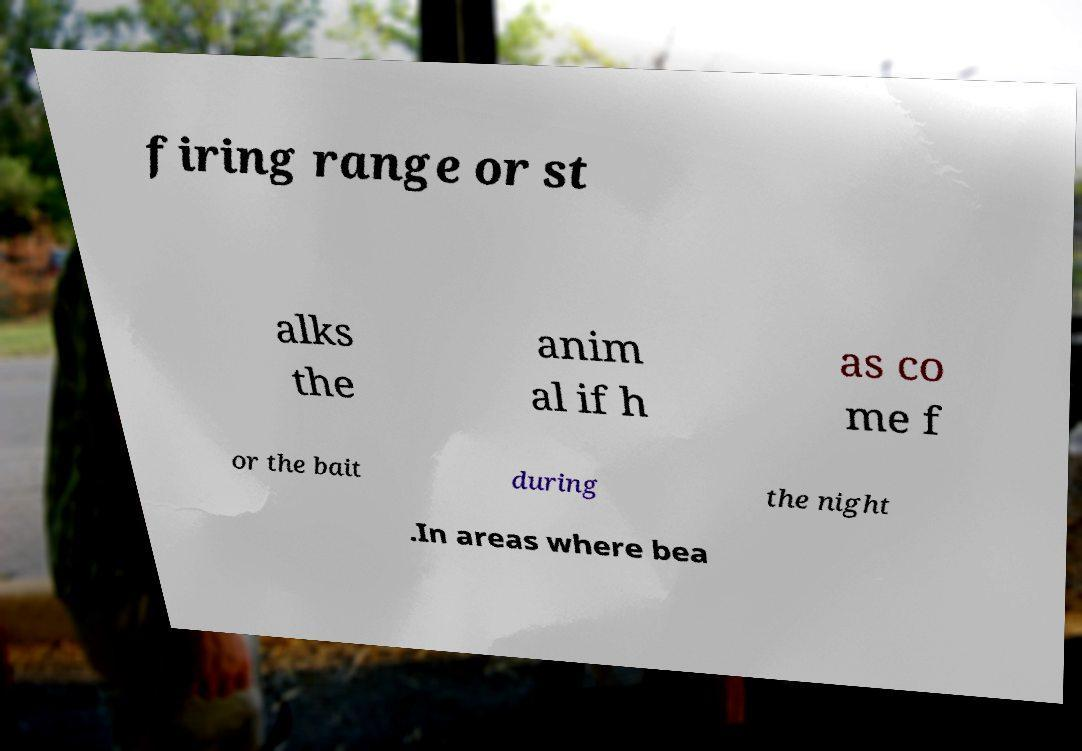Can you accurately transcribe the text from the provided image for me? firing range or st alks the anim al if h as co me f or the bait during the night .In areas where bea 